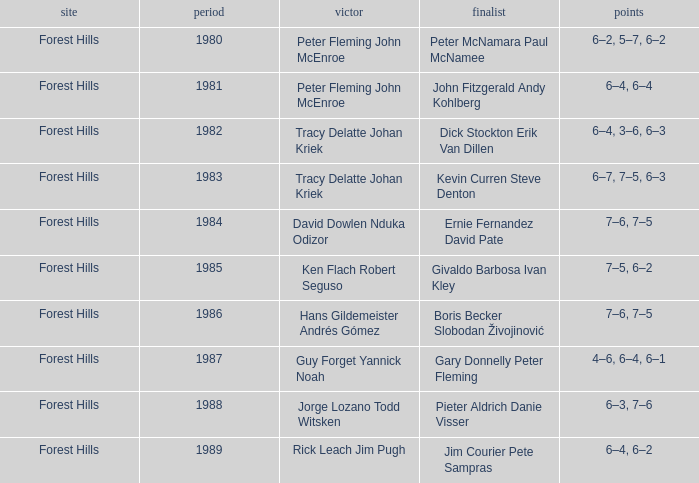Who was the runner-up in 1989? Jim Courier Pete Sampras. 